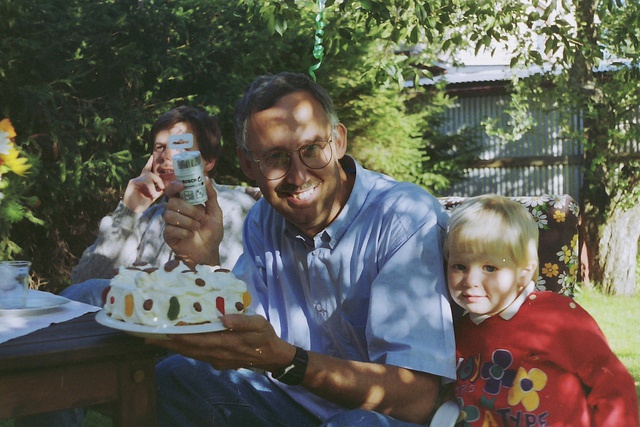Describe the objects in this image and their specific colors. I can see people in black, gray, and maroon tones, people in black, brown, maroon, and tan tones, people in black, gray, darkgray, and maroon tones, dining table in black and darkblue tones, and cake in black, darkgray, gray, and maroon tones in this image. 